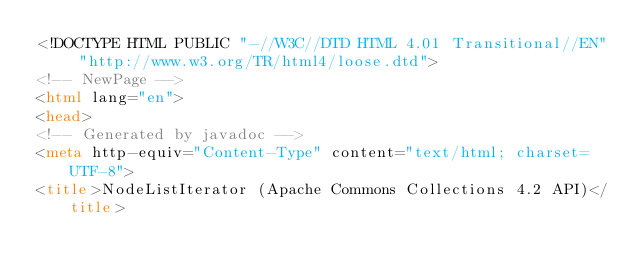<code> <loc_0><loc_0><loc_500><loc_500><_HTML_><!DOCTYPE HTML PUBLIC "-//W3C//DTD HTML 4.01 Transitional//EN" "http://www.w3.org/TR/html4/loose.dtd">
<!-- NewPage -->
<html lang="en">
<head>
<!-- Generated by javadoc -->
<meta http-equiv="Content-Type" content="text/html; charset=UTF-8">
<title>NodeListIterator (Apache Commons Collections 4.2 API)</title></code> 